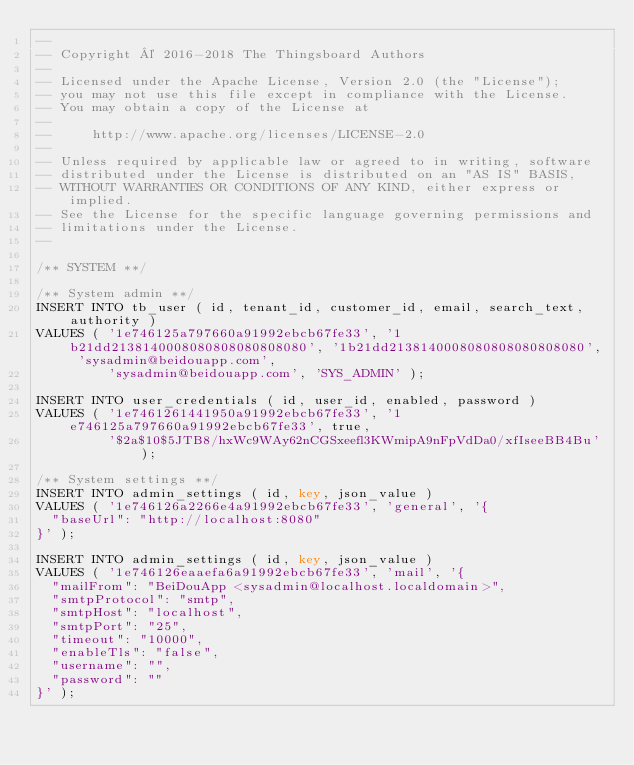Convert code to text. <code><loc_0><loc_0><loc_500><loc_500><_SQL_>--
-- Copyright © 2016-2018 The Thingsboard Authors
--
-- Licensed under the Apache License, Version 2.0 (the "License");
-- you may not use this file except in compliance with the License.
-- You may obtain a copy of the License at
--
--     http://www.apache.org/licenses/LICENSE-2.0
--
-- Unless required by applicable law or agreed to in writing, software
-- distributed under the License is distributed on an "AS IS" BASIS,
-- WITHOUT WARRANTIES OR CONDITIONS OF ANY KIND, either express or implied.
-- See the License for the specific language governing permissions and
-- limitations under the License.
--

/** SYSTEM **/

/** System admin **/
INSERT INTO tb_user ( id, tenant_id, customer_id, email, search_text, authority )
VALUES ( '1e746125a797660a91992ebcb67fe33', '1b21dd2138140008080808080808080', '1b21dd2138140008080808080808080', 'sysadmin@beidouapp.com',
         'sysadmin@beidouapp.com', 'SYS_ADMIN' );

INSERT INTO user_credentials ( id, user_id, enabled, password )
VALUES ( '1e7461261441950a91992ebcb67fe33', '1e746125a797660a91992ebcb67fe33', true,
         '$2a$10$5JTB8/hxWc9WAy62nCGSxeefl3KWmipA9nFpVdDa0/xfIseeBB4Bu' );

/** System settings **/
INSERT INTO admin_settings ( id, key, json_value )
VALUES ( '1e746126a2266e4a91992ebcb67fe33', 'general', '{
	"baseUrl": "http://localhost:8080"
}' );

INSERT INTO admin_settings ( id, key, json_value )
VALUES ( '1e746126eaaefa6a91992ebcb67fe33', 'mail', '{
	"mailFrom": "BeiDouApp <sysadmin@localhost.localdomain>",
	"smtpProtocol": "smtp",
	"smtpHost": "localhost",
	"smtpPort": "25",
	"timeout": "10000",
	"enableTls": "false",
	"username": "",
	"password": ""
}' );
</code> 